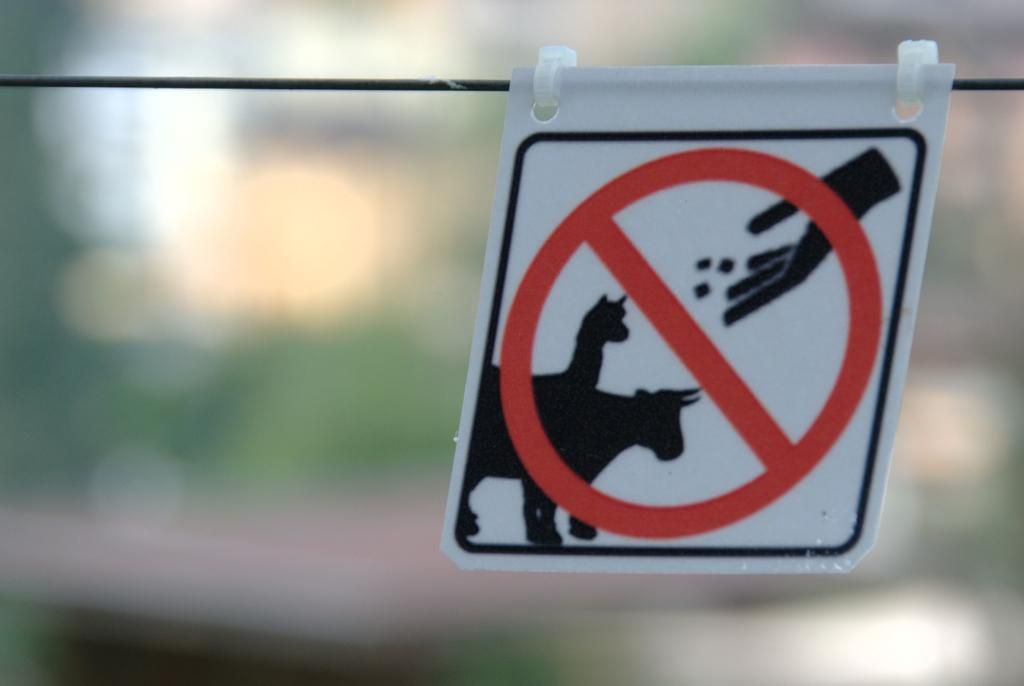What is the main object in the image? There is a danger sign board in the image. How is the sign board positioned or attached? The sign board is attached to a rope. What type of chalk is being used to write on the sign board in the image? There is no chalk or writing present on the sign board in the image. What kind of suit is the crook wearing in the image? There is no crook or person wearing a suit in the image; it only features a danger sign board attached to a rope. 